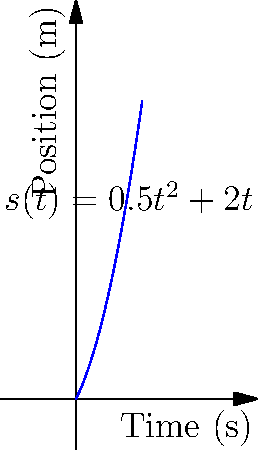As an e-bike store owner, you're testing a new model's performance. The graph shows the position $s(t)$ of the e-bike over time, where $s(t) = 0.5t^2 + 2t$ (in meters). Calculate the instantaneous velocity of the e-bike at $t = 3$ seconds. To find the instantaneous velocity at $t = 3$ seconds, we need to calculate the derivative of the position function at that point. Here's how we do it:

1) The position function is given as $s(t) = 0.5t^2 + 2t$

2) The velocity function $v(t)$ is the derivative of the position function:
   $v(t) = \frac{d}{dt}s(t) = \frac{d}{dt}(0.5t^2 + 2t)$

3) Using the power rule and constant rule of differentiation:
   $v(t) = 0.5 \cdot 2t^{2-1} + 2 = t + 2$

4) Now, we can calculate the velocity at $t = 3$ by plugging in this value:
   $v(3) = 3 + 2 = 5$

Therefore, the instantaneous velocity of the e-bike at $t = 3$ seconds is 5 m/s.
Answer: 5 m/s 